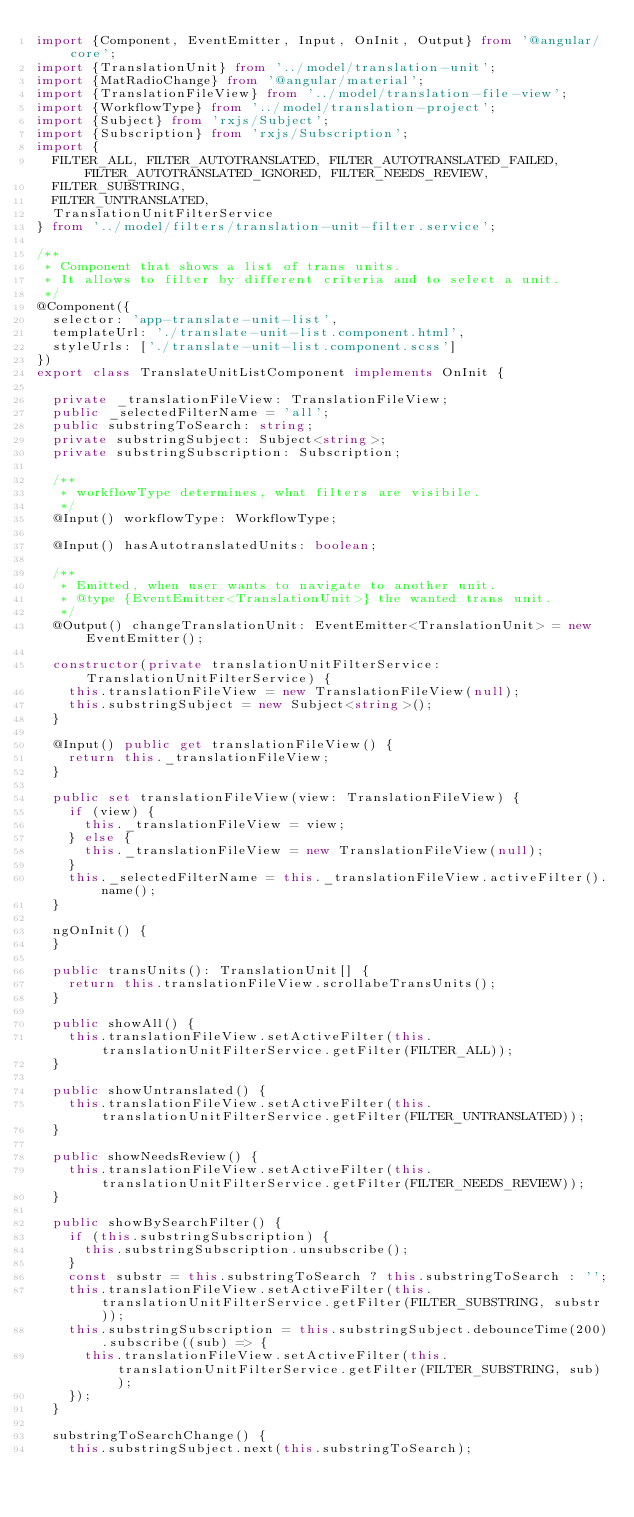Convert code to text. <code><loc_0><loc_0><loc_500><loc_500><_TypeScript_>import {Component, EventEmitter, Input, OnInit, Output} from '@angular/core';
import {TranslationUnit} from '../model/translation-unit';
import {MatRadioChange} from '@angular/material';
import {TranslationFileView} from '../model/translation-file-view';
import {WorkflowType} from '../model/translation-project';
import {Subject} from 'rxjs/Subject';
import {Subscription} from 'rxjs/Subscription';
import {
  FILTER_ALL, FILTER_AUTOTRANSLATED, FILTER_AUTOTRANSLATED_FAILED, FILTER_AUTOTRANSLATED_IGNORED, FILTER_NEEDS_REVIEW,
  FILTER_SUBSTRING,
  FILTER_UNTRANSLATED,
  TranslationUnitFilterService
} from '../model/filters/translation-unit-filter.service';

/**
 * Component that shows a list of trans units.
 * It allows to filter by different criteria and to select a unit.
 */
@Component({
  selector: 'app-translate-unit-list',
  templateUrl: './translate-unit-list.component.html',
  styleUrls: ['./translate-unit-list.component.scss']
})
export class TranslateUnitListComponent implements OnInit {

  private _translationFileView: TranslationFileView;
  public _selectedFilterName = 'all';
  public substringToSearch: string;
  private substringSubject: Subject<string>;
  private substringSubscription: Subscription;

  /**
   * workflowType determines, what filters are visibile.
   */
  @Input() workflowType: WorkflowType;

  @Input() hasAutotranslatedUnits: boolean;

  /**
   * Emitted, when user wants to navigate to another unit.
   * @type {EventEmitter<TranslationUnit>} the wanted trans unit.
   */
  @Output() changeTranslationUnit: EventEmitter<TranslationUnit> = new EventEmitter();

  constructor(private translationUnitFilterService: TranslationUnitFilterService) {
    this.translationFileView = new TranslationFileView(null);
    this.substringSubject = new Subject<string>();
  }

  @Input() public get translationFileView() {
    return this._translationFileView;
  }

  public set translationFileView(view: TranslationFileView) {
    if (view) {
      this._translationFileView = view;
    } else {
      this._translationFileView = new TranslationFileView(null);
    }
    this._selectedFilterName = this._translationFileView.activeFilter().name();
  }

  ngOnInit() {
  }

  public transUnits(): TranslationUnit[] {
    return this.translationFileView.scrollabeTransUnits();
  }

  public showAll() {
    this.translationFileView.setActiveFilter(this.translationUnitFilterService.getFilter(FILTER_ALL));
  }

  public showUntranslated() {
    this.translationFileView.setActiveFilter(this.translationUnitFilterService.getFilter(FILTER_UNTRANSLATED));
  }

  public showNeedsReview() {
    this.translationFileView.setActiveFilter(this.translationUnitFilterService.getFilter(FILTER_NEEDS_REVIEW));
  }

  public showBySearchFilter() {
    if (this.substringSubscription) {
      this.substringSubscription.unsubscribe();
    }
    const substr = this.substringToSearch ? this.substringToSearch : '';
    this.translationFileView.setActiveFilter(this.translationUnitFilterService.getFilter(FILTER_SUBSTRING, substr));
    this.substringSubscription = this.substringSubject.debounceTime(200).subscribe((sub) => {
      this.translationFileView.setActiveFilter(this.translationUnitFilterService.getFilter(FILTER_SUBSTRING, sub));
    });
  }

  substringToSearchChange() {
    this.substringSubject.next(this.substringToSearch);</code> 